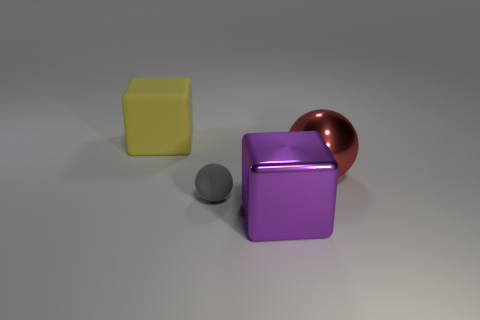What number of tiny objects have the same color as the big metallic sphere? There are no tiny objects that share the same color as the big metallic sphere. The sphere has a unique copper-like hue, whereas the other objects—a cube and a sphere—are yellow and grey, respectively. 